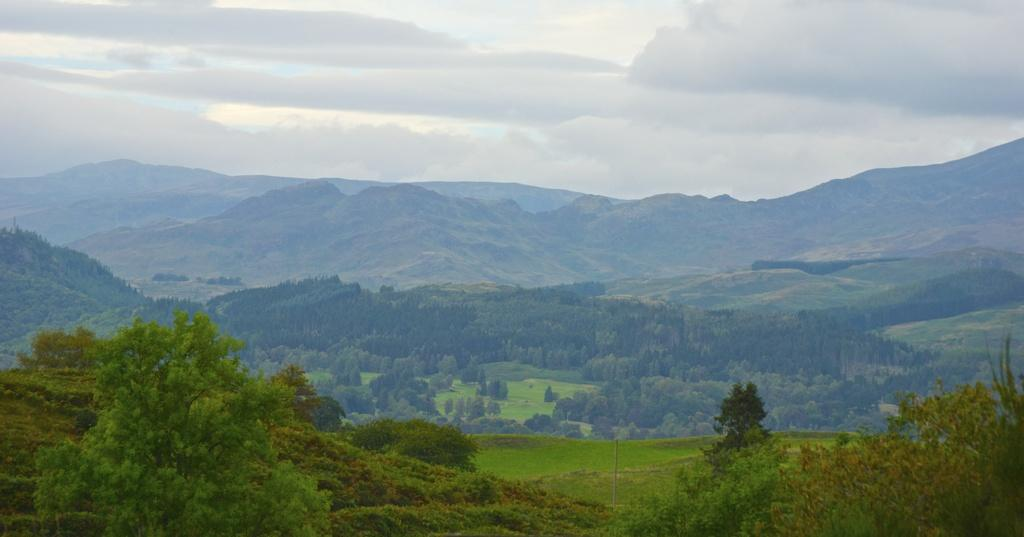What type of vegetation can be seen in the image? There are plants, grass, and trees in the image. What is the natural terrain visible in the image? There are hills in the image. What is visible in the sky in the image? There is sky visible in the image, and there are clouds in the sky. What type of rice is being cooked by the team in the image? There is no team or rice present in the image. What emotions are the plants feeling in the image? Plants do not have emotions, so this question cannot be answered. 